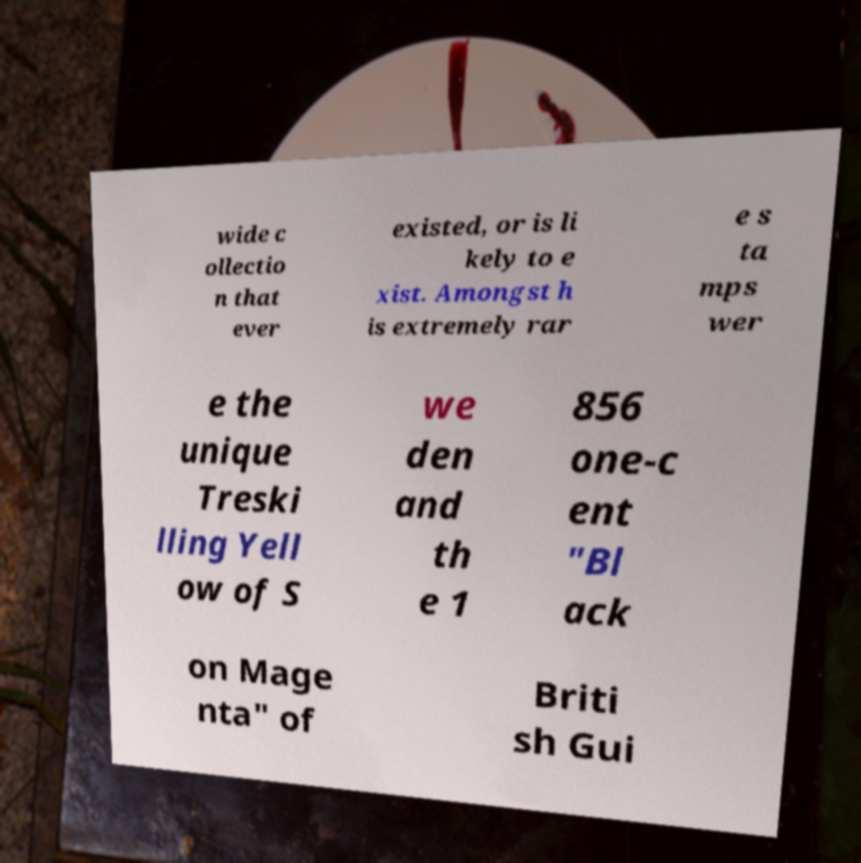Please read and relay the text visible in this image. What does it say? wide c ollectio n that ever existed, or is li kely to e xist. Amongst h is extremely rar e s ta mps wer e the unique Treski lling Yell ow of S we den and th e 1 856 one-c ent "Bl ack on Mage nta" of Briti sh Gui 